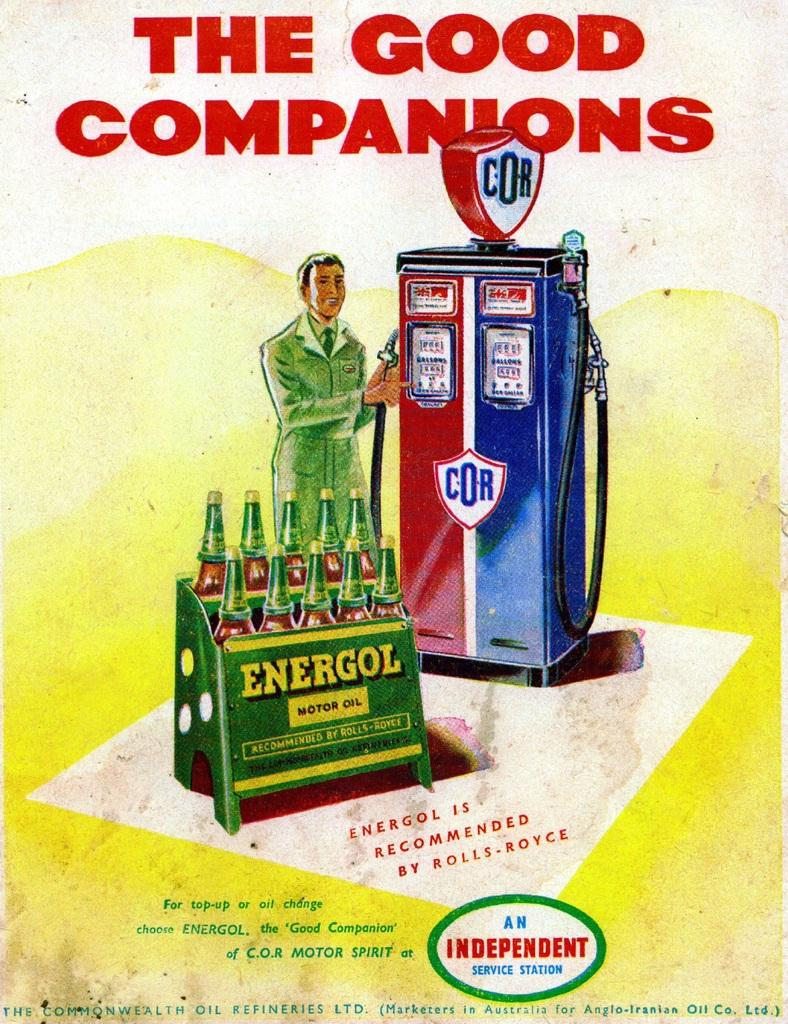<image>
Summarize the visual content of the image. The flyer advertises Energol motor oil which isn't around anymore. 